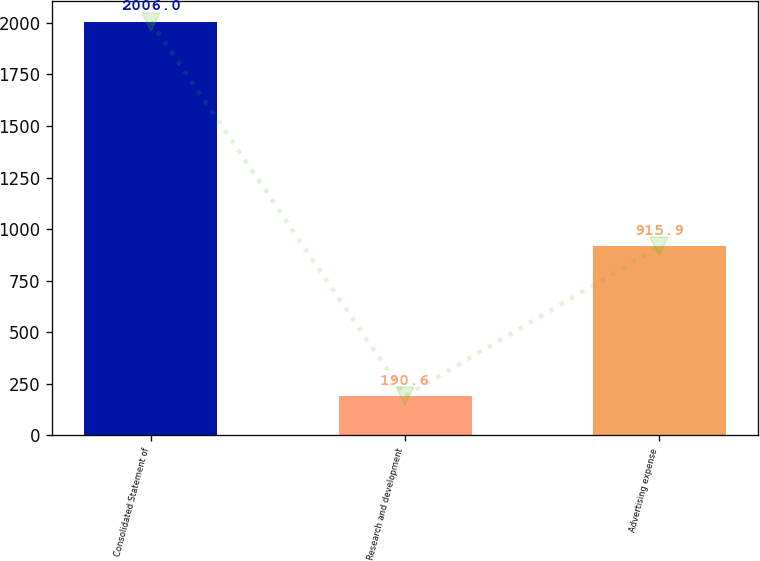<chart> <loc_0><loc_0><loc_500><loc_500><bar_chart><fcel>Consolidated Statement of<fcel>Research and development<fcel>Advertising expense<nl><fcel>2006<fcel>190.6<fcel>915.9<nl></chart> 